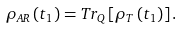Convert formula to latex. <formula><loc_0><loc_0><loc_500><loc_500>\rho _ { A R } \left ( t _ { 1 } \right ) = T r _ { Q } \left [ \rho _ { T } \left ( t _ { 1 } \right ) \right ] .</formula> 